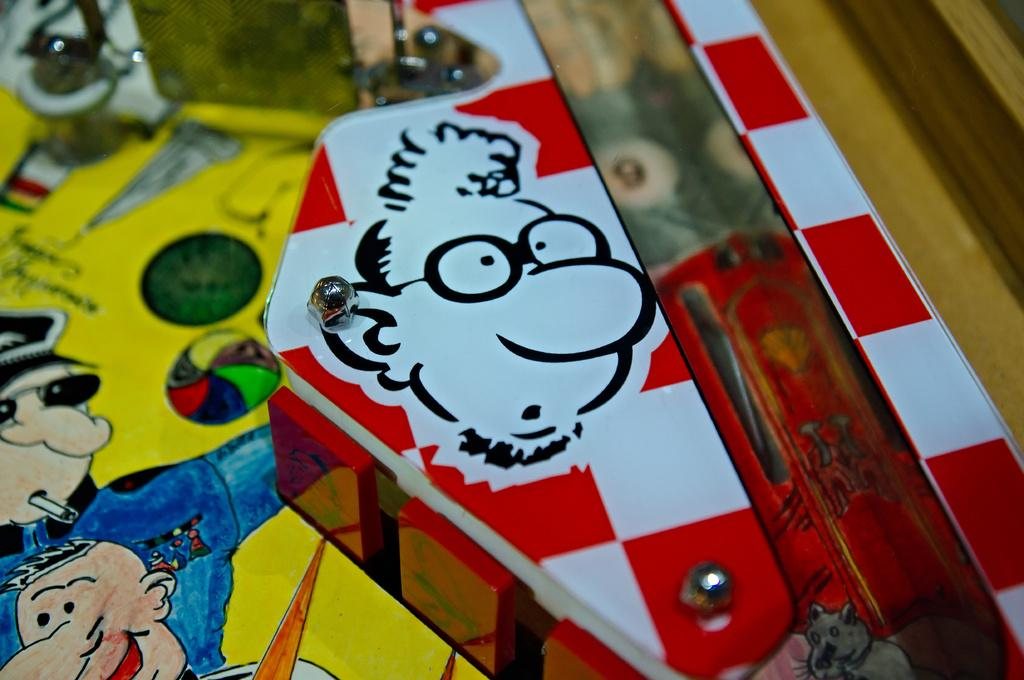What can be seen on the right side of the image? There is a cartoon on an object on the right side of the image. What is depicted on the left side of the image? There is a drawing on a paper on the left side of the image. How many cherries are hanging from the wish in the image? There is no mention of cherries or a wish in the image; it features a cartoon on the right side and a drawing on the left side. 